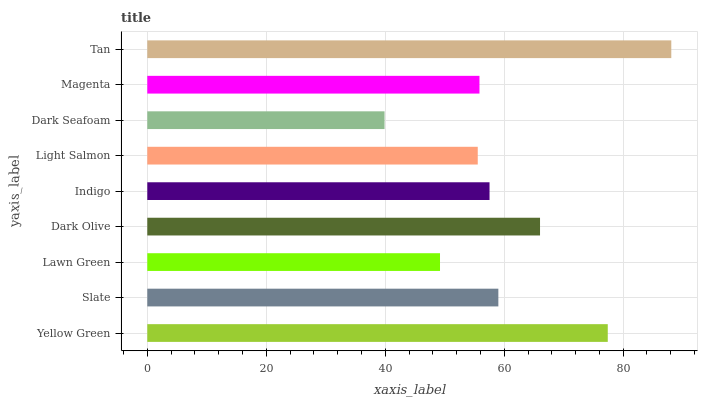Is Dark Seafoam the minimum?
Answer yes or no. Yes. Is Tan the maximum?
Answer yes or no. Yes. Is Slate the minimum?
Answer yes or no. No. Is Slate the maximum?
Answer yes or no. No. Is Yellow Green greater than Slate?
Answer yes or no. Yes. Is Slate less than Yellow Green?
Answer yes or no. Yes. Is Slate greater than Yellow Green?
Answer yes or no. No. Is Yellow Green less than Slate?
Answer yes or no. No. Is Indigo the high median?
Answer yes or no. Yes. Is Indigo the low median?
Answer yes or no. Yes. Is Dark Seafoam the high median?
Answer yes or no. No. Is Tan the low median?
Answer yes or no. No. 